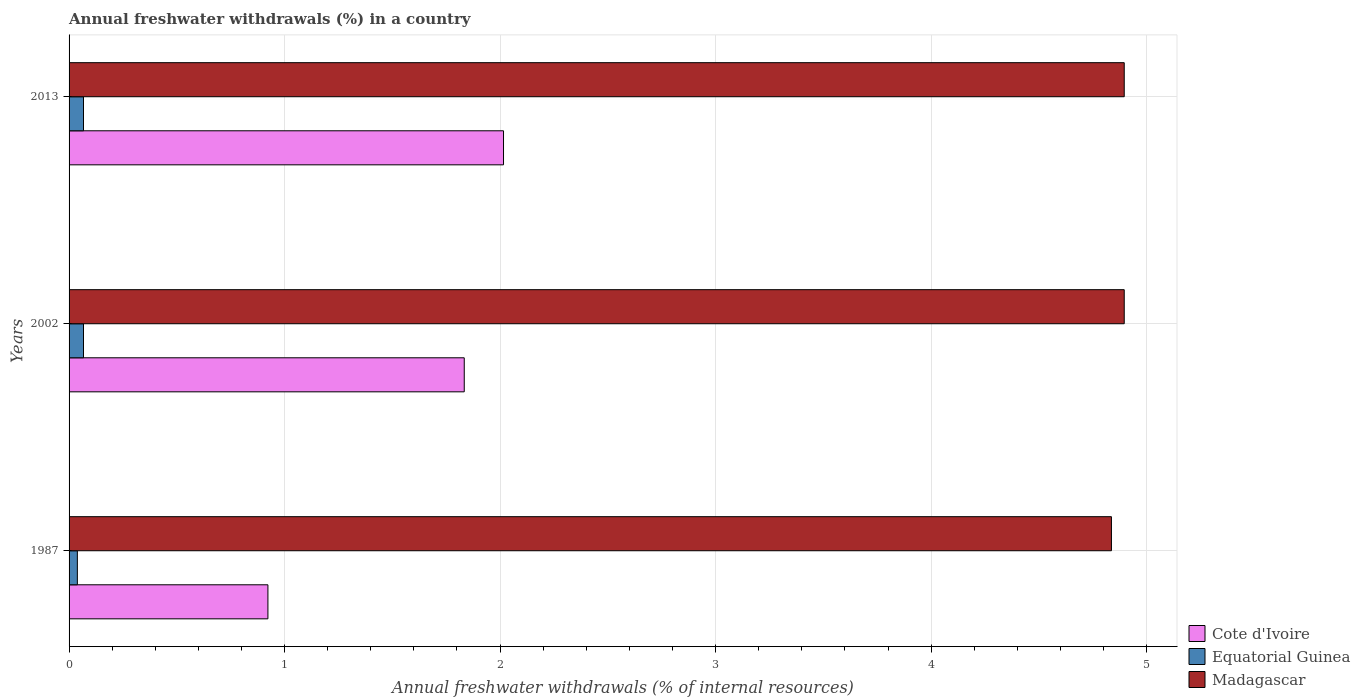How many groups of bars are there?
Offer a terse response. 3. Are the number of bars per tick equal to the number of legend labels?
Ensure brevity in your answer.  Yes. How many bars are there on the 2nd tick from the bottom?
Provide a short and direct response. 3. What is the label of the 1st group of bars from the top?
Make the answer very short. 2013. In how many cases, is the number of bars for a given year not equal to the number of legend labels?
Provide a succinct answer. 0. What is the percentage of annual freshwater withdrawals in Cote d'Ivoire in 2002?
Offer a terse response. 1.83. Across all years, what is the maximum percentage of annual freshwater withdrawals in Cote d'Ivoire?
Offer a very short reply. 2.02. Across all years, what is the minimum percentage of annual freshwater withdrawals in Madagascar?
Provide a short and direct response. 4.84. What is the total percentage of annual freshwater withdrawals in Madagascar in the graph?
Your response must be concise. 14.63. What is the difference between the percentage of annual freshwater withdrawals in Equatorial Guinea in 1987 and that in 2002?
Offer a terse response. -0.03. What is the difference between the percentage of annual freshwater withdrawals in Cote d'Ivoire in 1987 and the percentage of annual freshwater withdrawals in Equatorial Guinea in 2002?
Give a very brief answer. 0.86. What is the average percentage of annual freshwater withdrawals in Equatorial Guinea per year?
Your answer should be very brief. 0.06. In the year 2002, what is the difference between the percentage of annual freshwater withdrawals in Equatorial Guinea and percentage of annual freshwater withdrawals in Cote d'Ivoire?
Offer a terse response. -1.77. What is the ratio of the percentage of annual freshwater withdrawals in Madagascar in 1987 to that in 2002?
Keep it short and to the point. 0.99. Is the percentage of annual freshwater withdrawals in Madagascar in 1987 less than that in 2002?
Provide a short and direct response. Yes. What is the difference between the highest and the second highest percentage of annual freshwater withdrawals in Cote d'Ivoire?
Your answer should be compact. 0.18. What is the difference between the highest and the lowest percentage of annual freshwater withdrawals in Madagascar?
Provide a succinct answer. 0.06. Is the sum of the percentage of annual freshwater withdrawals in Cote d'Ivoire in 2002 and 2013 greater than the maximum percentage of annual freshwater withdrawals in Madagascar across all years?
Ensure brevity in your answer.  No. What does the 1st bar from the top in 2013 represents?
Give a very brief answer. Madagascar. What does the 1st bar from the bottom in 2002 represents?
Offer a very short reply. Cote d'Ivoire. Is it the case that in every year, the sum of the percentage of annual freshwater withdrawals in Cote d'Ivoire and percentage of annual freshwater withdrawals in Madagascar is greater than the percentage of annual freshwater withdrawals in Equatorial Guinea?
Your answer should be compact. Yes. Are all the bars in the graph horizontal?
Offer a very short reply. Yes. What is the difference between two consecutive major ticks on the X-axis?
Provide a succinct answer. 1. Are the values on the major ticks of X-axis written in scientific E-notation?
Your response must be concise. No. Does the graph contain grids?
Give a very brief answer. Yes. Where does the legend appear in the graph?
Provide a short and direct response. Bottom right. How many legend labels are there?
Keep it short and to the point. 3. How are the legend labels stacked?
Offer a very short reply. Vertical. What is the title of the graph?
Your response must be concise. Annual freshwater withdrawals (%) in a country. Does "Malaysia" appear as one of the legend labels in the graph?
Ensure brevity in your answer.  No. What is the label or title of the X-axis?
Provide a short and direct response. Annual freshwater withdrawals (% of internal resources). What is the Annual freshwater withdrawals (% of internal resources) in Cote d'Ivoire in 1987?
Offer a very short reply. 0.92. What is the Annual freshwater withdrawals (% of internal resources) of Equatorial Guinea in 1987?
Ensure brevity in your answer.  0.04. What is the Annual freshwater withdrawals (% of internal resources) of Madagascar in 1987?
Provide a short and direct response. 4.84. What is the Annual freshwater withdrawals (% of internal resources) of Cote d'Ivoire in 2002?
Your answer should be compact. 1.83. What is the Annual freshwater withdrawals (% of internal resources) of Equatorial Guinea in 2002?
Offer a very short reply. 0.07. What is the Annual freshwater withdrawals (% of internal resources) of Madagascar in 2002?
Make the answer very short. 4.9. What is the Annual freshwater withdrawals (% of internal resources) in Cote d'Ivoire in 2013?
Make the answer very short. 2.02. What is the Annual freshwater withdrawals (% of internal resources) of Equatorial Guinea in 2013?
Provide a short and direct response. 0.07. What is the Annual freshwater withdrawals (% of internal resources) of Madagascar in 2013?
Ensure brevity in your answer.  4.9. Across all years, what is the maximum Annual freshwater withdrawals (% of internal resources) of Cote d'Ivoire?
Your answer should be compact. 2.02. Across all years, what is the maximum Annual freshwater withdrawals (% of internal resources) in Equatorial Guinea?
Your answer should be very brief. 0.07. Across all years, what is the maximum Annual freshwater withdrawals (% of internal resources) of Madagascar?
Offer a very short reply. 4.9. Across all years, what is the minimum Annual freshwater withdrawals (% of internal resources) of Cote d'Ivoire?
Offer a terse response. 0.92. Across all years, what is the minimum Annual freshwater withdrawals (% of internal resources) of Equatorial Guinea?
Your response must be concise. 0.04. Across all years, what is the minimum Annual freshwater withdrawals (% of internal resources) of Madagascar?
Give a very brief answer. 4.84. What is the total Annual freshwater withdrawals (% of internal resources) in Cote d'Ivoire in the graph?
Your answer should be very brief. 4.77. What is the total Annual freshwater withdrawals (% of internal resources) in Equatorial Guinea in the graph?
Offer a very short reply. 0.17. What is the total Annual freshwater withdrawals (% of internal resources) of Madagascar in the graph?
Keep it short and to the point. 14.63. What is the difference between the Annual freshwater withdrawals (% of internal resources) in Cote d'Ivoire in 1987 and that in 2002?
Provide a short and direct response. -0.91. What is the difference between the Annual freshwater withdrawals (% of internal resources) of Equatorial Guinea in 1987 and that in 2002?
Ensure brevity in your answer.  -0.03. What is the difference between the Annual freshwater withdrawals (% of internal resources) of Madagascar in 1987 and that in 2002?
Provide a succinct answer. -0.06. What is the difference between the Annual freshwater withdrawals (% of internal resources) of Cote d'Ivoire in 1987 and that in 2013?
Ensure brevity in your answer.  -1.09. What is the difference between the Annual freshwater withdrawals (% of internal resources) of Equatorial Guinea in 1987 and that in 2013?
Make the answer very short. -0.03. What is the difference between the Annual freshwater withdrawals (% of internal resources) of Madagascar in 1987 and that in 2013?
Offer a terse response. -0.06. What is the difference between the Annual freshwater withdrawals (% of internal resources) in Cote d'Ivoire in 2002 and that in 2013?
Make the answer very short. -0.18. What is the difference between the Annual freshwater withdrawals (% of internal resources) of Madagascar in 2002 and that in 2013?
Keep it short and to the point. 0. What is the difference between the Annual freshwater withdrawals (% of internal resources) in Cote d'Ivoire in 1987 and the Annual freshwater withdrawals (% of internal resources) in Equatorial Guinea in 2002?
Keep it short and to the point. 0.86. What is the difference between the Annual freshwater withdrawals (% of internal resources) of Cote d'Ivoire in 1987 and the Annual freshwater withdrawals (% of internal resources) of Madagascar in 2002?
Your response must be concise. -3.97. What is the difference between the Annual freshwater withdrawals (% of internal resources) of Equatorial Guinea in 1987 and the Annual freshwater withdrawals (% of internal resources) of Madagascar in 2002?
Your response must be concise. -4.86. What is the difference between the Annual freshwater withdrawals (% of internal resources) of Cote d'Ivoire in 1987 and the Annual freshwater withdrawals (% of internal resources) of Equatorial Guinea in 2013?
Provide a short and direct response. 0.86. What is the difference between the Annual freshwater withdrawals (% of internal resources) in Cote d'Ivoire in 1987 and the Annual freshwater withdrawals (% of internal resources) in Madagascar in 2013?
Keep it short and to the point. -3.97. What is the difference between the Annual freshwater withdrawals (% of internal resources) in Equatorial Guinea in 1987 and the Annual freshwater withdrawals (% of internal resources) in Madagascar in 2013?
Keep it short and to the point. -4.86. What is the difference between the Annual freshwater withdrawals (% of internal resources) of Cote d'Ivoire in 2002 and the Annual freshwater withdrawals (% of internal resources) of Equatorial Guinea in 2013?
Your answer should be very brief. 1.77. What is the difference between the Annual freshwater withdrawals (% of internal resources) of Cote d'Ivoire in 2002 and the Annual freshwater withdrawals (% of internal resources) of Madagascar in 2013?
Make the answer very short. -3.06. What is the difference between the Annual freshwater withdrawals (% of internal resources) in Equatorial Guinea in 2002 and the Annual freshwater withdrawals (% of internal resources) in Madagascar in 2013?
Your answer should be compact. -4.83. What is the average Annual freshwater withdrawals (% of internal resources) in Cote d'Ivoire per year?
Your answer should be very brief. 1.59. What is the average Annual freshwater withdrawals (% of internal resources) in Equatorial Guinea per year?
Your answer should be very brief. 0.06. What is the average Annual freshwater withdrawals (% of internal resources) in Madagascar per year?
Offer a very short reply. 4.88. In the year 1987, what is the difference between the Annual freshwater withdrawals (% of internal resources) of Cote d'Ivoire and Annual freshwater withdrawals (% of internal resources) of Equatorial Guinea?
Give a very brief answer. 0.88. In the year 1987, what is the difference between the Annual freshwater withdrawals (% of internal resources) of Cote d'Ivoire and Annual freshwater withdrawals (% of internal resources) of Madagascar?
Give a very brief answer. -3.91. In the year 1987, what is the difference between the Annual freshwater withdrawals (% of internal resources) in Equatorial Guinea and Annual freshwater withdrawals (% of internal resources) in Madagascar?
Offer a terse response. -4.8. In the year 2002, what is the difference between the Annual freshwater withdrawals (% of internal resources) in Cote d'Ivoire and Annual freshwater withdrawals (% of internal resources) in Equatorial Guinea?
Your answer should be very brief. 1.77. In the year 2002, what is the difference between the Annual freshwater withdrawals (% of internal resources) in Cote d'Ivoire and Annual freshwater withdrawals (% of internal resources) in Madagascar?
Give a very brief answer. -3.06. In the year 2002, what is the difference between the Annual freshwater withdrawals (% of internal resources) in Equatorial Guinea and Annual freshwater withdrawals (% of internal resources) in Madagascar?
Give a very brief answer. -4.83. In the year 2013, what is the difference between the Annual freshwater withdrawals (% of internal resources) in Cote d'Ivoire and Annual freshwater withdrawals (% of internal resources) in Equatorial Guinea?
Make the answer very short. 1.95. In the year 2013, what is the difference between the Annual freshwater withdrawals (% of internal resources) of Cote d'Ivoire and Annual freshwater withdrawals (% of internal resources) of Madagascar?
Offer a very short reply. -2.88. In the year 2013, what is the difference between the Annual freshwater withdrawals (% of internal resources) in Equatorial Guinea and Annual freshwater withdrawals (% of internal resources) in Madagascar?
Offer a terse response. -4.83. What is the ratio of the Annual freshwater withdrawals (% of internal resources) in Cote d'Ivoire in 1987 to that in 2002?
Keep it short and to the point. 0.5. What is the ratio of the Annual freshwater withdrawals (% of internal resources) in Equatorial Guinea in 1987 to that in 2002?
Give a very brief answer. 0.57. What is the ratio of the Annual freshwater withdrawals (% of internal resources) of Madagascar in 1987 to that in 2002?
Offer a very short reply. 0.99. What is the ratio of the Annual freshwater withdrawals (% of internal resources) in Cote d'Ivoire in 1987 to that in 2013?
Offer a very short reply. 0.46. What is the ratio of the Annual freshwater withdrawals (% of internal resources) of Equatorial Guinea in 1987 to that in 2013?
Keep it short and to the point. 0.57. What is the ratio of the Annual freshwater withdrawals (% of internal resources) in Madagascar in 1987 to that in 2013?
Ensure brevity in your answer.  0.99. What is the ratio of the Annual freshwater withdrawals (% of internal resources) of Cote d'Ivoire in 2002 to that in 2013?
Offer a very short reply. 0.91. What is the ratio of the Annual freshwater withdrawals (% of internal resources) in Madagascar in 2002 to that in 2013?
Keep it short and to the point. 1. What is the difference between the highest and the second highest Annual freshwater withdrawals (% of internal resources) of Cote d'Ivoire?
Your answer should be very brief. 0.18. What is the difference between the highest and the second highest Annual freshwater withdrawals (% of internal resources) of Equatorial Guinea?
Ensure brevity in your answer.  0. What is the difference between the highest and the second highest Annual freshwater withdrawals (% of internal resources) of Madagascar?
Offer a very short reply. 0. What is the difference between the highest and the lowest Annual freshwater withdrawals (% of internal resources) in Cote d'Ivoire?
Give a very brief answer. 1.09. What is the difference between the highest and the lowest Annual freshwater withdrawals (% of internal resources) of Equatorial Guinea?
Give a very brief answer. 0.03. What is the difference between the highest and the lowest Annual freshwater withdrawals (% of internal resources) of Madagascar?
Ensure brevity in your answer.  0.06. 